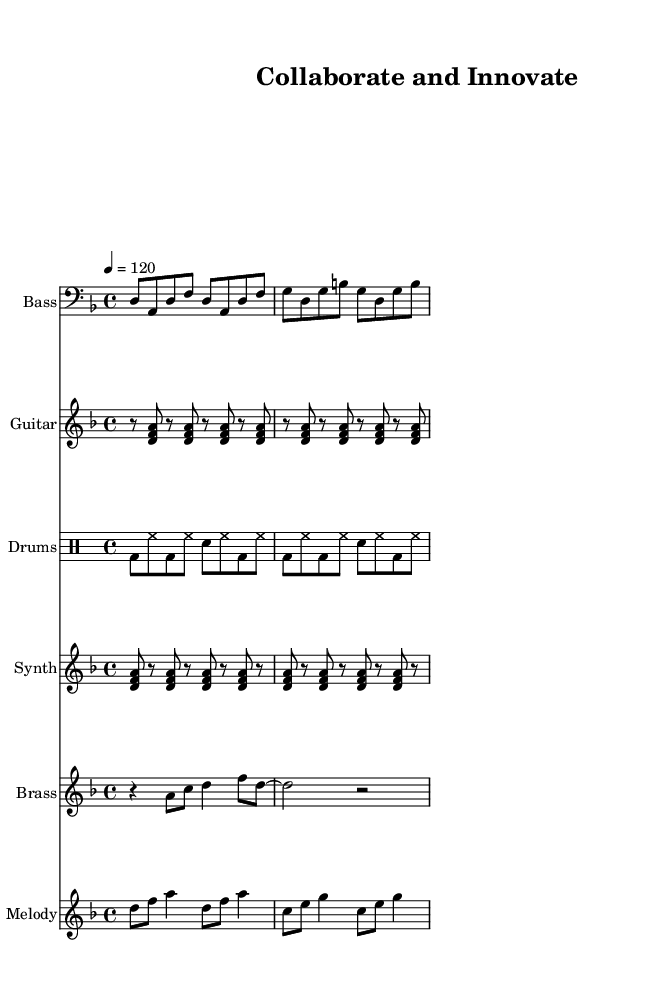What is the key signature of this music? The key signature is D minor, which is indicated by one flat (B flat) in the key signature.
Answer: D minor What is the time signature of this piece? The time signature is found at the start of the score, showing 4/4, meaning there are four beats in each measure and the quarter note gets one beat.
Answer: 4/4 What is the tempo marking for the piece? The tempo marking indicates that the piece should be played at a speed of 120 beats per minute, noted as "4 = 120" in the score.
Answer: 120 Which instruments are included in this composition? The score lists multiple instruments including Bass, Guitar, Drums, Synth, Brass, and Melody, reflecting the diverse arrangement typical in funk music.
Answer: Bass, Guitar, Drums, Synth, Brass, Melody What is the rhythmic pattern used in the drum part? The drum groove consists of a basic rhythm pattern alternating between bass drum and hi-hat, with snare hits on the 2nd and 4th beats, typical for funk music to create a danceable groove.
Answer: Alternating bass and hi-hat with snare on 2 and 4 How many measures are in the bass line? The bass line is divided into four measures, with each measure containing specific note patterns typical of funk styles, reflecting a consistent rhythmic foundation.
Answer: 4 What section features the brass instruments prominently? The brass melody section prominently features a syncopated rhythm, which is a characteristic element of funk music, emphasizing accents in unexpected places for a lively sound.
Answer: Brass melody section 